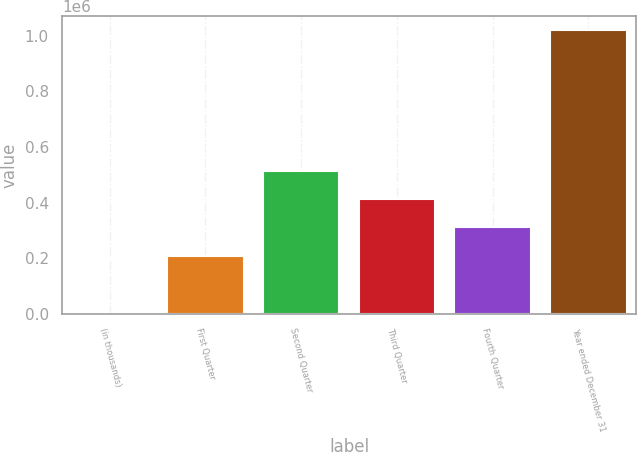Convert chart. <chart><loc_0><loc_0><loc_500><loc_500><bar_chart><fcel>(in thousands)<fcel>First Quarter<fcel>Second Quarter<fcel>Third Quarter<fcel>Fourth Quarter<fcel>Year ended December 31<nl><fcel>2008<fcel>210078<fcel>515645<fcel>413789<fcel>311934<fcel>1.02056e+06<nl></chart> 